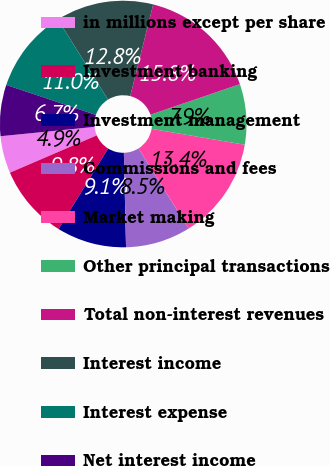Convert chart. <chart><loc_0><loc_0><loc_500><loc_500><pie_chart><fcel>in millions except per share<fcel>Investment banking<fcel>Investment management<fcel>Commissions and fees<fcel>Market making<fcel>Other principal transactions<fcel>Total non-interest revenues<fcel>Interest income<fcel>Interest expense<fcel>Net interest income<nl><fcel>4.88%<fcel>9.76%<fcel>9.15%<fcel>8.54%<fcel>13.41%<fcel>7.93%<fcel>15.85%<fcel>12.8%<fcel>10.98%<fcel>6.71%<nl></chart> 